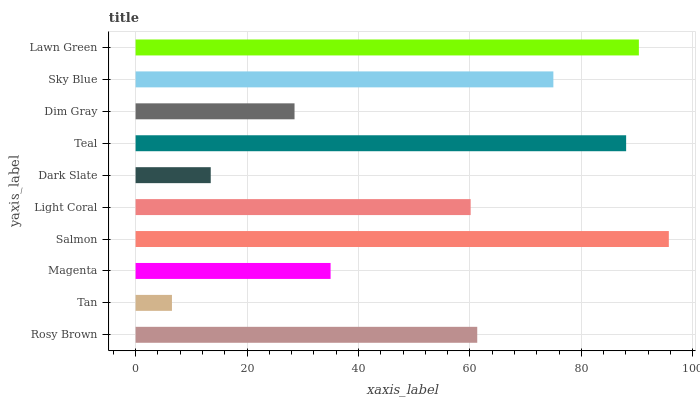Is Tan the minimum?
Answer yes or no. Yes. Is Salmon the maximum?
Answer yes or no. Yes. Is Magenta the minimum?
Answer yes or no. No. Is Magenta the maximum?
Answer yes or no. No. Is Magenta greater than Tan?
Answer yes or no. Yes. Is Tan less than Magenta?
Answer yes or no. Yes. Is Tan greater than Magenta?
Answer yes or no. No. Is Magenta less than Tan?
Answer yes or no. No. Is Rosy Brown the high median?
Answer yes or no. Yes. Is Light Coral the low median?
Answer yes or no. Yes. Is Dark Slate the high median?
Answer yes or no. No. Is Tan the low median?
Answer yes or no. No. 